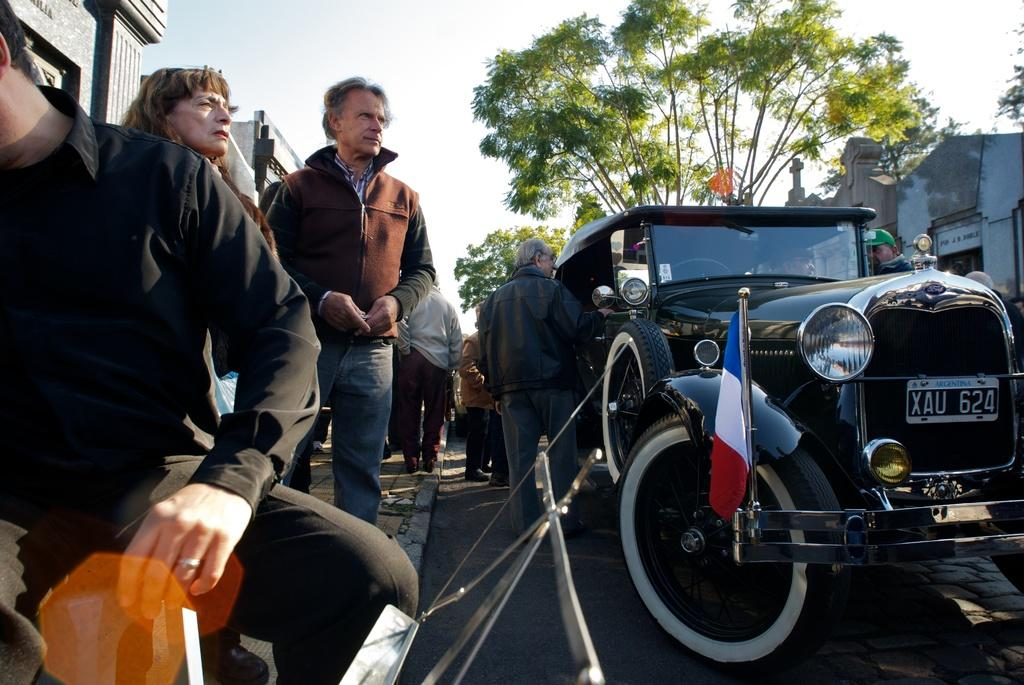What is present in the image besides the persons standing? There is a black vehicle with a flag in the image. What can be seen in the distance in the image? There are buildings and a tree visible in the distance. What type of ice can be seen melting on the hood of the vehicle in the image? There is no ice visible on the vehicle in the image. Can you describe the dinosaurs that are walking around the persons in the image? There are no dinosaurs present in the image. 